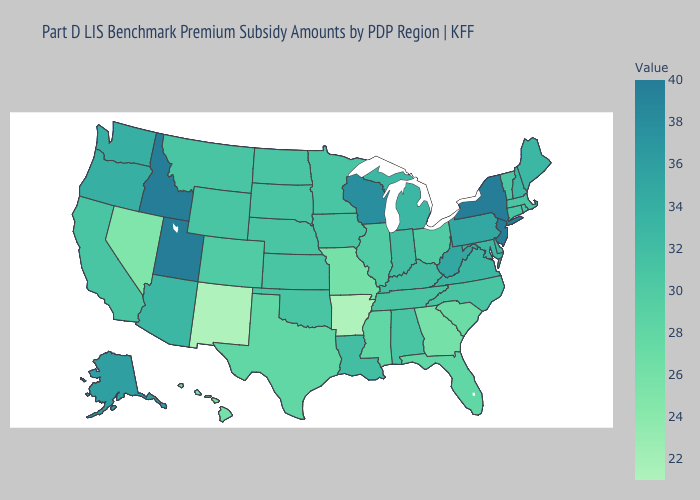Which states have the highest value in the USA?
Answer briefly. Idaho, New Jersey, New York, Utah. Does Georgia have a higher value than New Mexico?
Be succinct. Yes. Which states hav the highest value in the South?
Concise answer only. West Virginia. Does Massachusetts have a higher value than Nevada?
Write a very short answer. Yes. Among the states that border Oklahoma , does Arkansas have the lowest value?
Be succinct. Yes. 